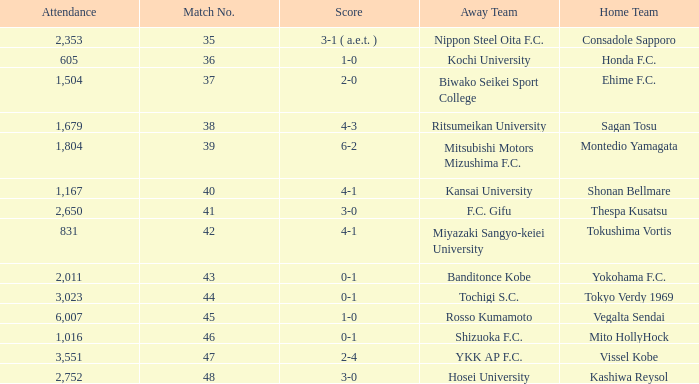After Match 43, what was the Attendance of the Match with a Score of 2-4? 3551.0. 